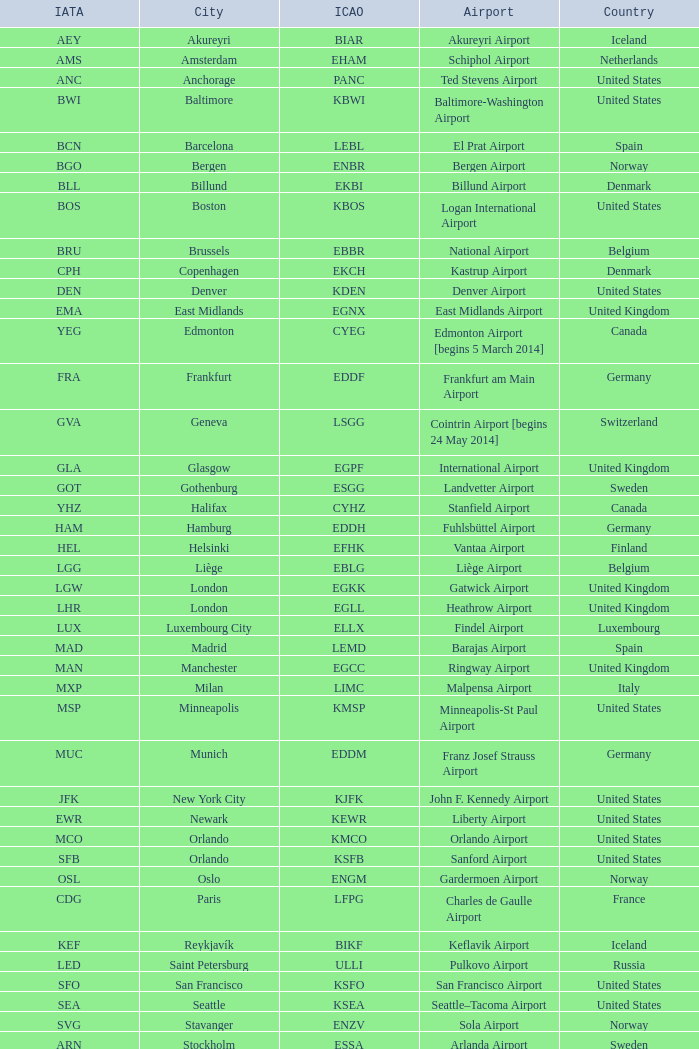Parse the full table. {'header': ['IATA', 'City', 'ICAO', 'Airport', 'Country'], 'rows': [['AEY', 'Akureyri', 'BIAR', 'Akureyri Airport', 'Iceland'], ['AMS', 'Amsterdam', 'EHAM', 'Schiphol Airport', 'Netherlands'], ['ANC', 'Anchorage', 'PANC', 'Ted Stevens Airport', 'United States'], ['BWI', 'Baltimore', 'KBWI', 'Baltimore-Washington Airport', 'United States'], ['BCN', 'Barcelona', 'LEBL', 'El Prat Airport', 'Spain'], ['BGO', 'Bergen', 'ENBR', 'Bergen Airport', 'Norway'], ['BLL', 'Billund', 'EKBI', 'Billund Airport', 'Denmark'], ['BOS', 'Boston', 'KBOS', 'Logan International Airport', 'United States'], ['BRU', 'Brussels', 'EBBR', 'National Airport', 'Belgium'], ['CPH', 'Copenhagen', 'EKCH', 'Kastrup Airport', 'Denmark'], ['DEN', 'Denver', 'KDEN', 'Denver Airport', 'United States'], ['EMA', 'East Midlands', 'EGNX', 'East Midlands Airport', 'United Kingdom'], ['YEG', 'Edmonton', 'CYEG', 'Edmonton Airport [begins 5 March 2014]', 'Canada'], ['FRA', 'Frankfurt', 'EDDF', 'Frankfurt am Main Airport', 'Germany'], ['GVA', 'Geneva', 'LSGG', 'Cointrin Airport [begins 24 May 2014]', 'Switzerland'], ['GLA', 'Glasgow', 'EGPF', 'International Airport', 'United Kingdom'], ['GOT', 'Gothenburg', 'ESGG', 'Landvetter Airport', 'Sweden'], ['YHZ', 'Halifax', 'CYHZ', 'Stanfield Airport', 'Canada'], ['HAM', 'Hamburg', 'EDDH', 'Fuhlsbüttel Airport', 'Germany'], ['HEL', 'Helsinki', 'EFHK', 'Vantaa Airport', 'Finland'], ['LGG', 'Liège', 'EBLG', 'Liège Airport', 'Belgium'], ['LGW', 'London', 'EGKK', 'Gatwick Airport', 'United Kingdom'], ['LHR', 'London', 'EGLL', 'Heathrow Airport', 'United Kingdom'], ['LUX', 'Luxembourg City', 'ELLX', 'Findel Airport', 'Luxembourg'], ['MAD', 'Madrid', 'LEMD', 'Barajas Airport', 'Spain'], ['MAN', 'Manchester', 'EGCC', 'Ringway Airport', 'United Kingdom'], ['MXP', 'Milan', 'LIMC', 'Malpensa Airport', 'Italy'], ['MSP', 'Minneapolis', 'KMSP', 'Minneapolis-St Paul Airport', 'United States'], ['MUC', 'Munich', 'EDDM', 'Franz Josef Strauss Airport', 'Germany'], ['JFK', 'New York City', 'KJFK', 'John F. Kennedy Airport', 'United States'], ['EWR', 'Newark', 'KEWR', 'Liberty Airport', 'United States'], ['MCO', 'Orlando', 'KMCO', 'Orlando Airport', 'United States'], ['SFB', 'Orlando', 'KSFB', 'Sanford Airport', 'United States'], ['OSL', 'Oslo', 'ENGM', 'Gardermoen Airport', 'Norway'], ['CDG', 'Paris', 'LFPG', 'Charles de Gaulle Airport', 'France'], ['KEF', 'Reykjavík', 'BIKF', 'Keflavik Airport', 'Iceland'], ['LED', 'Saint Petersburg', 'ULLI', 'Pulkovo Airport', 'Russia'], ['SFO', 'San Francisco', 'KSFO', 'San Francisco Airport', 'United States'], ['SEA', 'Seattle', 'KSEA', 'Seattle–Tacoma Airport', 'United States'], ['SVG', 'Stavanger', 'ENZV', 'Sola Airport', 'Norway'], ['ARN', 'Stockholm', 'ESSA', 'Arlanda Airport', 'Sweden'], ['YYZ', 'Toronto', 'CYYZ', 'Pearson Airport', 'Canada'], ['TRD', 'Trondheim', 'ENVA', 'Trondheim Airport', 'Norway'], ['YVR', 'Vancouver', 'CYVR', 'Vancouver Airport [begins 13 May 2014]', 'Canada'], ['IAD', 'Washington, D.C.', 'KIAD', 'Dulles Airport', 'United States'], ['ZRH', 'Zurich', 'LSZH', 'Kloten Airport', 'Switzerland']]} What is the IATA OF Akureyri? AEY. 